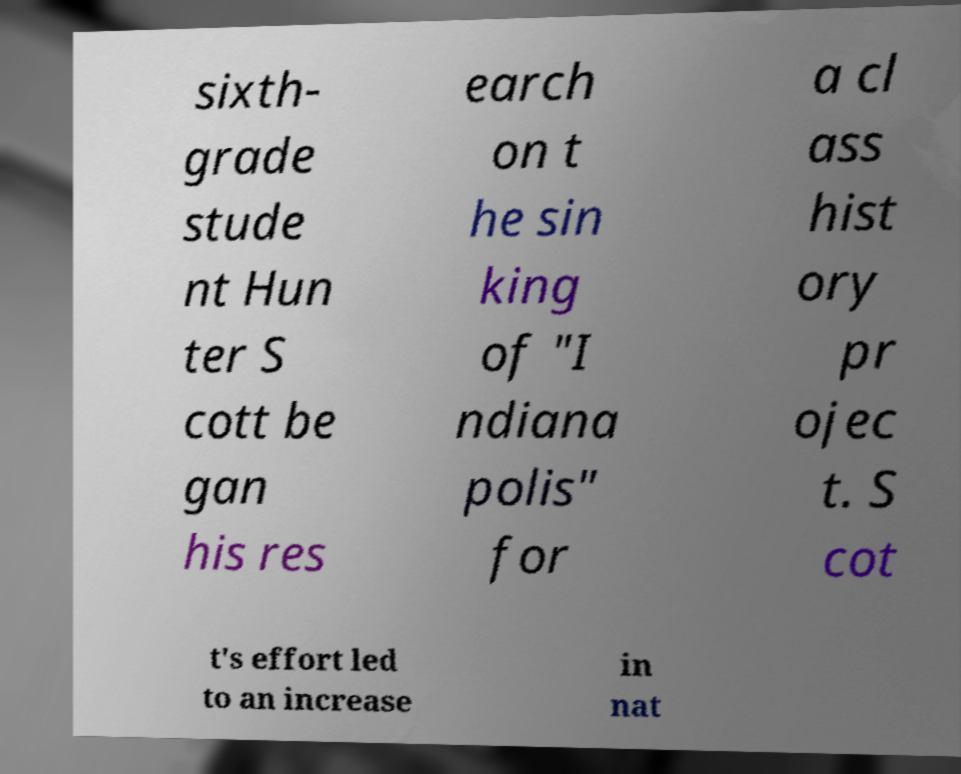Please identify and transcribe the text found in this image. sixth- grade stude nt Hun ter S cott be gan his res earch on t he sin king of "I ndiana polis" for a cl ass hist ory pr ojec t. S cot t's effort led to an increase in nat 